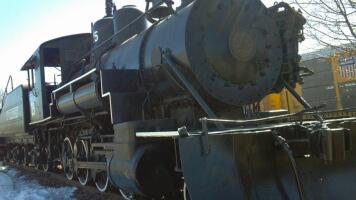Is this an old train?
Write a very short answer. Yes. Is this train in motion?
Be succinct. No. Which train has a logo that resembles the American flag?
Quick response, please. Right one. 